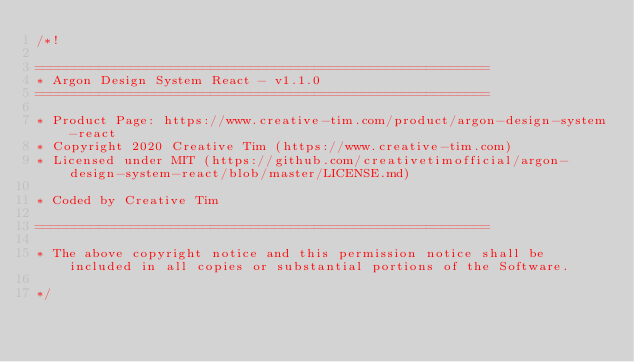<code> <loc_0><loc_0><loc_500><loc_500><_CSS_>/*!

=========================================================
* Argon Design System React - v1.1.0
=========================================================

* Product Page: https://www.creative-tim.com/product/argon-design-system-react
* Copyright 2020 Creative Tim (https://www.creative-tim.com)
* Licensed under MIT (https://github.com/creativetimofficial/argon-design-system-react/blob/master/LICENSE.md)

* Coded by Creative Tim

=========================================================

* The above copyright notice and this permission notice shall be included in all copies or substantial portions of the Software.

*/</code> 